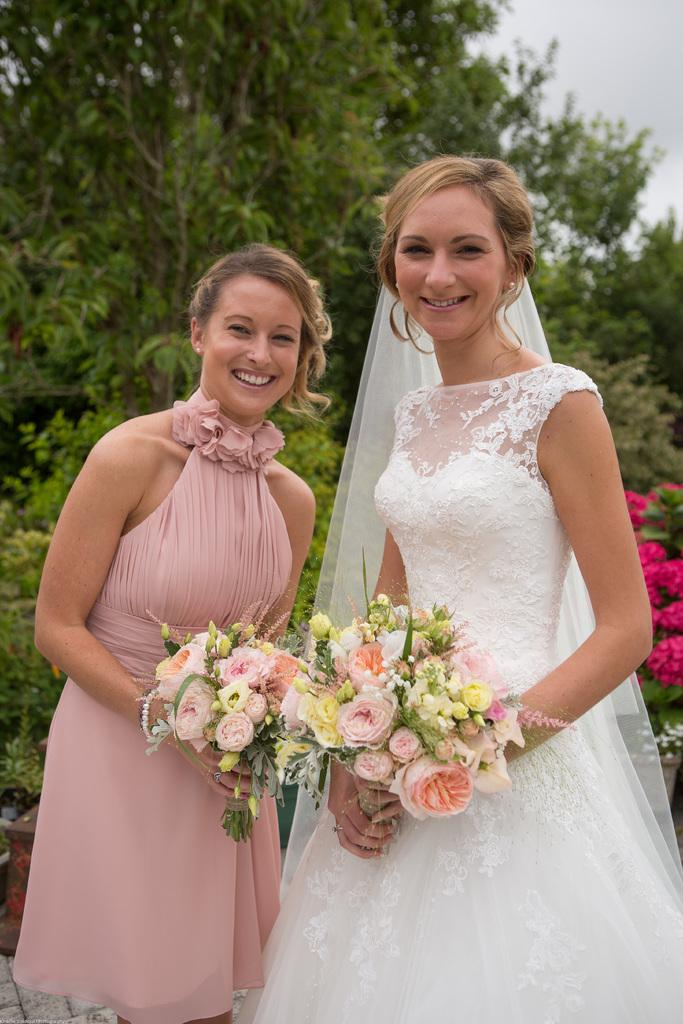How many people are in the image? There are two persons in the image. What are the persons doing in the image? The persons are standing and smiling. What are the persons holding in the image? They are holding flower bouquets. What can be seen in the background of the image? There are flowers, trees, and the sky visible in the background of the image. What type of bone can be seen in the image? There is no bone present in the image. Can you tell me how many uncles are in the image? The provided facts do not mention any uncles in the image. 